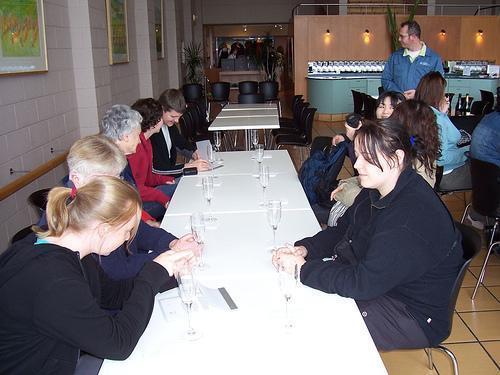How many dining tables are there?
Give a very brief answer. 2. How many people can you see?
Give a very brief answer. 9. 